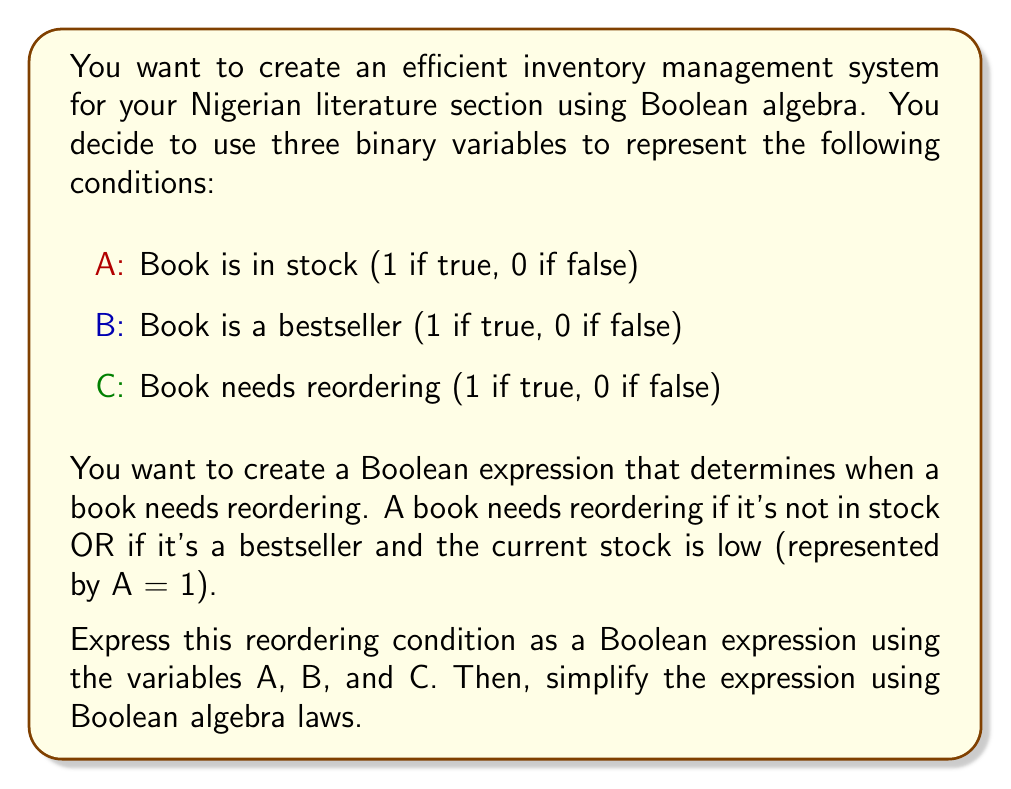Give your solution to this math problem. Let's approach this step-by-step:

1. First, we need to translate the reordering condition into a Boolean expression:
   - A book needs reordering (C = 1) if:
     a) It's not in stock (A = 0), OR
     b) It's a bestseller (B = 1) and the current stock is low (A = 1)

2. We can express this as:
   $$ C = \overline{A} + (B \cdot A) $$

3. Now, let's simplify this expression using Boolean algebra laws:
   $$ C = \overline{A} + (B \cdot A) $$
   $$ = \overline{A} + BA \quad \text{(dropping the parentheses)} $$

4. We can further simplify this using the absorption law: $X + \overline{X}Y = X + Y$
   In our case, $X = \overline{A}$ and $Y = B$:
   $$ C = \overline{A} + BA $$
   $$ = \overline{A} + B $$

5. This simplified expression means that a book needs reordering if it's not in stock OR if it's a bestseller, regardless of its current stock status.

This simplification makes the inventory management system more efficient by reducing the number of logical operations needed to determine if a book needs reordering.
Answer: $$ C = \overline{A} + B $$ 